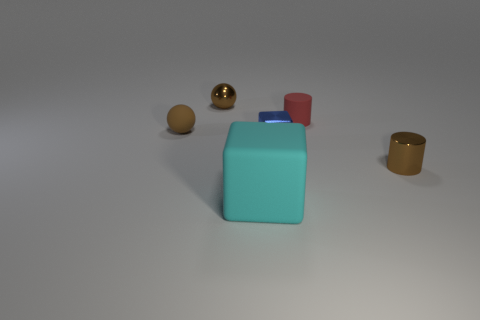Subtract all brown cylinders. Subtract all cyan spheres. How many cylinders are left? 1 Add 3 yellow metal balls. How many objects exist? 9 Subtract all cylinders. How many objects are left? 4 Add 6 tiny brown metallic balls. How many tiny brown metallic balls are left? 7 Add 2 tiny blue things. How many tiny blue things exist? 3 Subtract 0 yellow spheres. How many objects are left? 6 Subtract all large cyan rubber cubes. Subtract all tiny shiny cylinders. How many objects are left? 4 